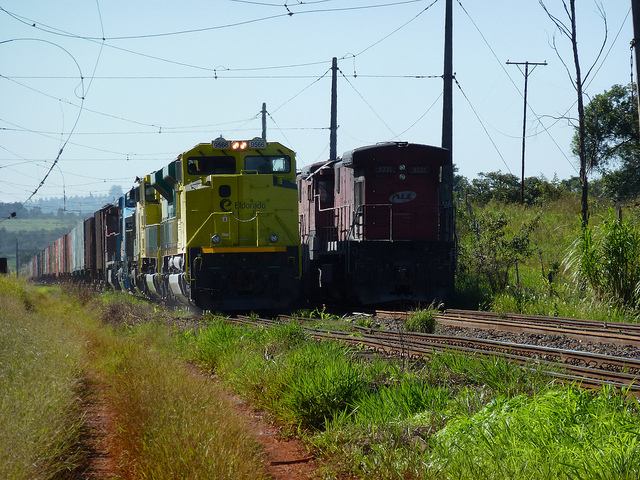Please transcribe the text in this image. Eldorado 